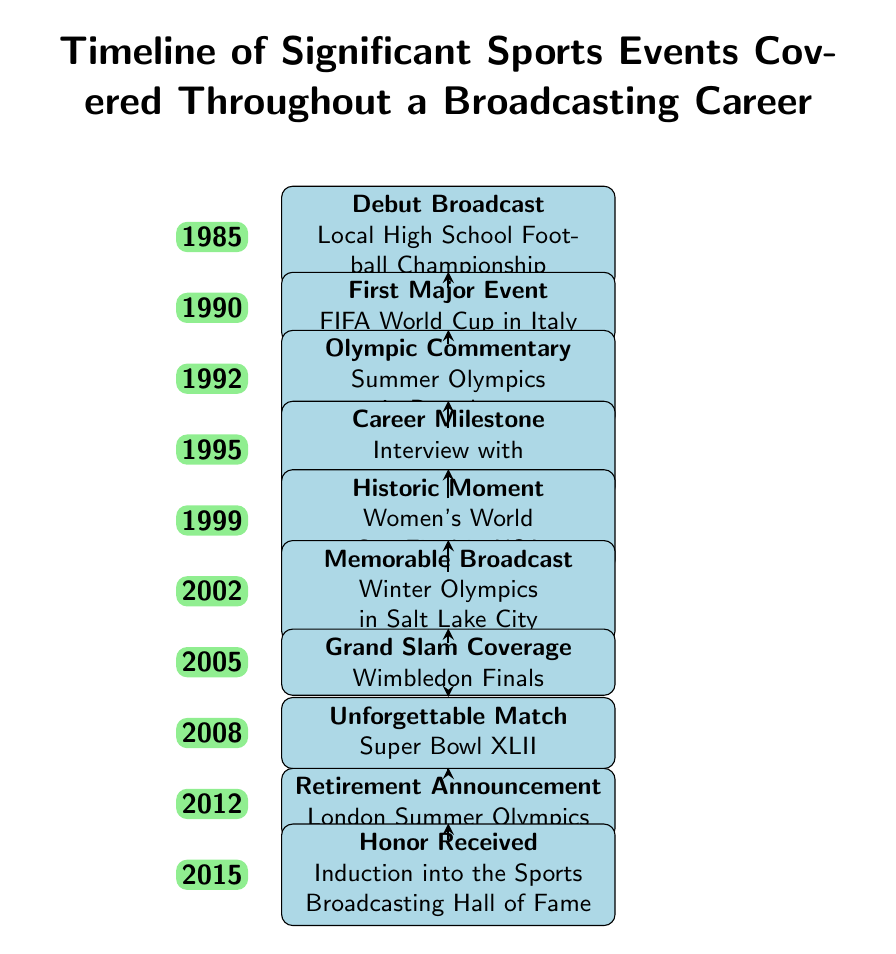What year did the broadcaster cover their debut event? The diagram indicates that the debut broadcast took place in 1985, as noted beside the corresponding event node.
Answer: 1985 How many major events are listed in the timeline? Upon examining the events included, there are ten distinct events mentioned, each identified by its year and description.
Answer: 10 What event occurred immediately after the interview with Michael Jordan? By following the timeline, the event listed after the interview in 1995 is the Women's World Cup Final in 1999, which is marked as a historic moment.
Answer: Women's World Cup Final What is the year the broadcaster announced their retirement? The timeline specifies that the retirement announcement was made in 2012, which is provided directly alongside that event node.
Answer: 2012 Which event is associated with the year 2008? The diagram shows that in 2008, the unforgettable match that is highlighted is Super Bowl XLII, prominently presented in that section of the timeline.
Answer: Super Bowl XLII What was the first major event the broadcaster covered? The timeline indicates that the first major event covered was the FIFA World Cup in Italy, which took place in 1990, as noted in the corresponding event description.
Answer: FIFA World Cup in Italy What significant honor did the broadcaster receive in 2015? The timeline details that in 2015, the broadcaster was inducted into the Sports Broadcasting Hall of Fame, which is a significant recognition noted in the timeline.
Answer: Induction into the Sports Broadcasting Hall of Fame Which milestone event involved the Summer Olympics? Based on the diagram, the event linked to the Summer Olympics was Olympic Commentary in 1992, detailing that specific event and year.
Answer: Olympic Commentary Which event marks the end of the timeline? The final event on the timeline is the Honor Received in 2015 for induction into the Sports Broadcasting Hall of Fame, making it the last listed event.
Answer: Induction into the Sports Broadcasting Hall of Fame 